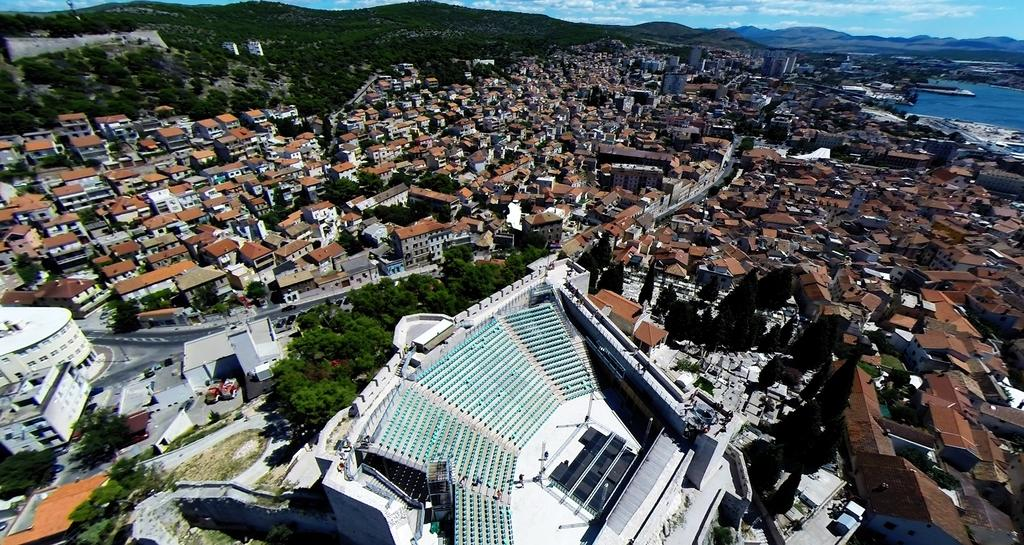What type of view is shown in the image? The image is an aerial view. What structures can be seen in the city? There are buildings in the city. What natural elements are present in the city? There are trees in the city. How are the buildings and trees connected in the city? There are roads in the city that connect the buildings and trees. What can be seen in the background of the image? In the background, there are mountains and water visible. What is the condition of the sky in the image? The sky is visible in the background, and there are clouds present. What type of furniture can be seen in the image? There is no furniture present in the image, as it is an aerial view of a city. How many deer are visible in the image? There are no deer present in the image; it is a view of a city with buildings, trees, roads, mountains, water, and clouds. 